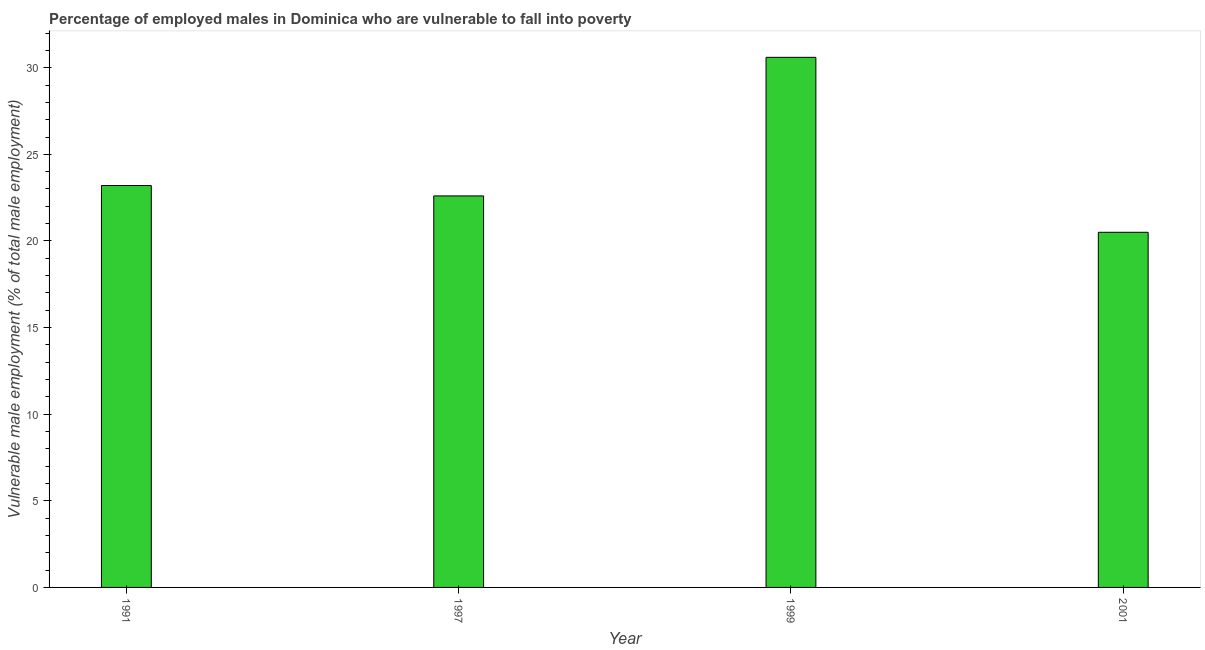Does the graph contain any zero values?
Offer a very short reply. No. Does the graph contain grids?
Offer a very short reply. No. What is the title of the graph?
Your answer should be compact. Percentage of employed males in Dominica who are vulnerable to fall into poverty. What is the label or title of the Y-axis?
Your answer should be compact. Vulnerable male employment (% of total male employment). What is the percentage of employed males who are vulnerable to fall into poverty in 1997?
Provide a succinct answer. 22.6. Across all years, what is the maximum percentage of employed males who are vulnerable to fall into poverty?
Your response must be concise. 30.6. In which year was the percentage of employed males who are vulnerable to fall into poverty maximum?
Keep it short and to the point. 1999. In which year was the percentage of employed males who are vulnerable to fall into poverty minimum?
Your response must be concise. 2001. What is the sum of the percentage of employed males who are vulnerable to fall into poverty?
Provide a succinct answer. 96.9. What is the difference between the percentage of employed males who are vulnerable to fall into poverty in 1997 and 2001?
Offer a very short reply. 2.1. What is the average percentage of employed males who are vulnerable to fall into poverty per year?
Provide a short and direct response. 24.23. What is the median percentage of employed males who are vulnerable to fall into poverty?
Ensure brevity in your answer.  22.9. In how many years, is the percentage of employed males who are vulnerable to fall into poverty greater than 2 %?
Your answer should be compact. 4. What is the ratio of the percentage of employed males who are vulnerable to fall into poverty in 1991 to that in 1997?
Give a very brief answer. 1.03. Is the percentage of employed males who are vulnerable to fall into poverty in 1991 less than that in 1999?
Provide a short and direct response. Yes. Is the difference between the percentage of employed males who are vulnerable to fall into poverty in 1991 and 2001 greater than the difference between any two years?
Keep it short and to the point. No. What is the difference between the highest and the second highest percentage of employed males who are vulnerable to fall into poverty?
Offer a terse response. 7.4. What is the difference between the highest and the lowest percentage of employed males who are vulnerable to fall into poverty?
Make the answer very short. 10.1. How many bars are there?
Ensure brevity in your answer.  4. Are all the bars in the graph horizontal?
Your answer should be compact. No. Are the values on the major ticks of Y-axis written in scientific E-notation?
Your response must be concise. No. What is the Vulnerable male employment (% of total male employment) of 1991?
Your response must be concise. 23.2. What is the Vulnerable male employment (% of total male employment) of 1997?
Your answer should be compact. 22.6. What is the Vulnerable male employment (% of total male employment) in 1999?
Your response must be concise. 30.6. What is the difference between the Vulnerable male employment (% of total male employment) in 1991 and 2001?
Offer a terse response. 2.7. What is the ratio of the Vulnerable male employment (% of total male employment) in 1991 to that in 1999?
Provide a succinct answer. 0.76. What is the ratio of the Vulnerable male employment (% of total male employment) in 1991 to that in 2001?
Keep it short and to the point. 1.13. What is the ratio of the Vulnerable male employment (% of total male employment) in 1997 to that in 1999?
Give a very brief answer. 0.74. What is the ratio of the Vulnerable male employment (% of total male employment) in 1997 to that in 2001?
Ensure brevity in your answer.  1.1. What is the ratio of the Vulnerable male employment (% of total male employment) in 1999 to that in 2001?
Ensure brevity in your answer.  1.49. 